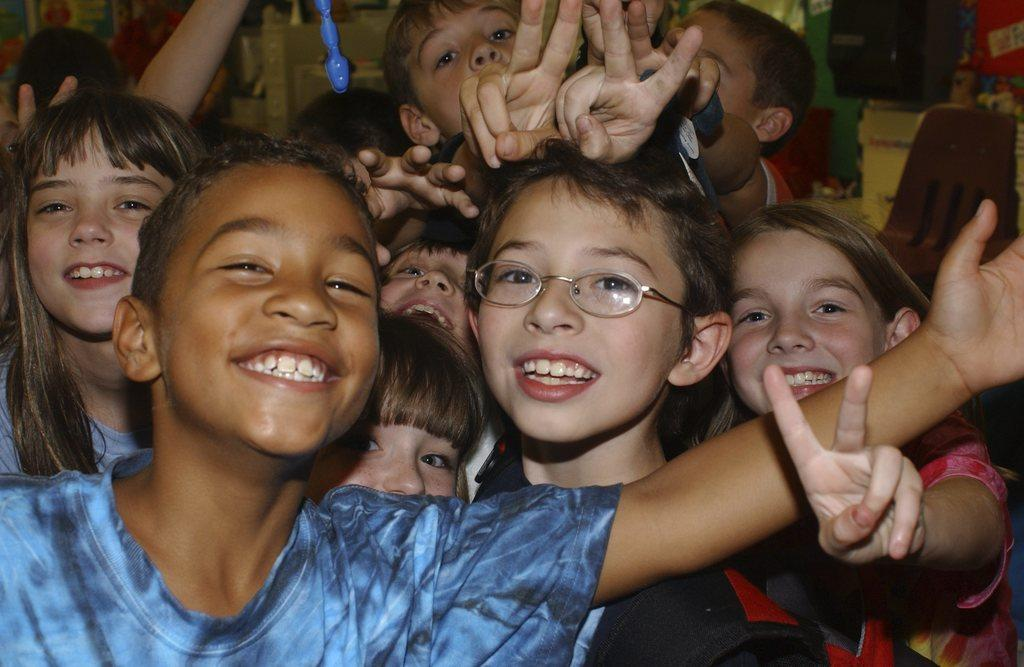How many kids are present in the image? There are many kids in the image. Can you describe one of the kids in the image? There is a kid with spectacles in the image. What else can be seen in the background of the image? There are other things visible in the background of the image. What type of crack can be seen on the ground in the image? There is no crack visible on the ground in the image. How many goats are present in the image? There are no goats present in the image. 